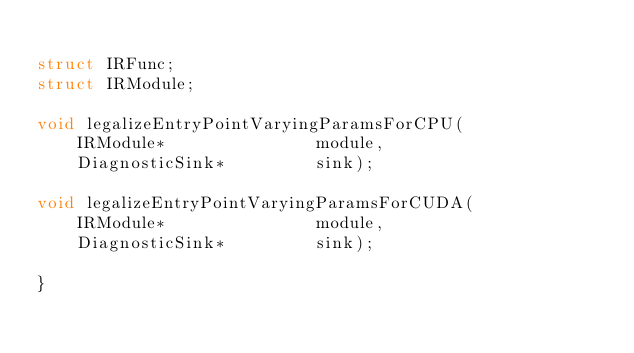<code> <loc_0><loc_0><loc_500><loc_500><_C_>
struct IRFunc;
struct IRModule;

void legalizeEntryPointVaryingParamsForCPU(
    IRModule*               module,
    DiagnosticSink*         sink);

void legalizeEntryPointVaryingParamsForCUDA(
    IRModule*               module,
    DiagnosticSink*         sink);

}
</code> 